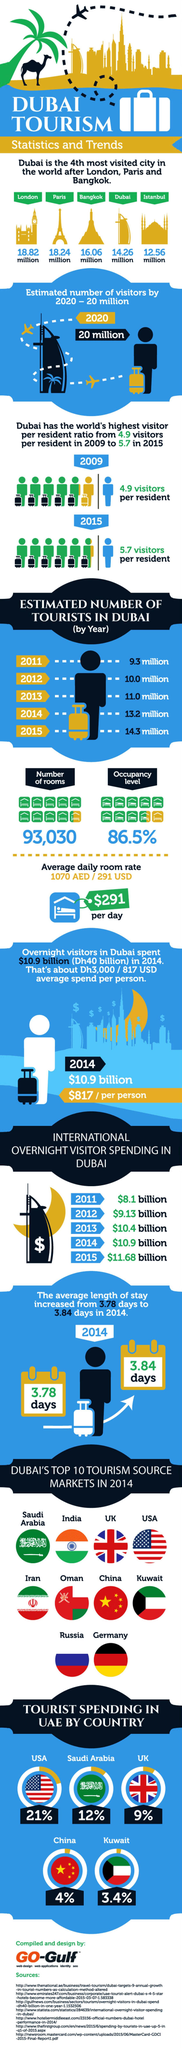Identify some key points in this picture. According to data, Saudi Arabia spends approximately 12% of its total budget on attracting tourists. The combined international overnight visitor spending in Dubai in the years 2011 and 2012 was $17.23 billion. Bangkok is the third most visited city in the world. The combined amount of money spent by Saudi Arabia and the UK on tourism is 21%. In 2011 and 2012, a total of 19.3 million tourists visited. 